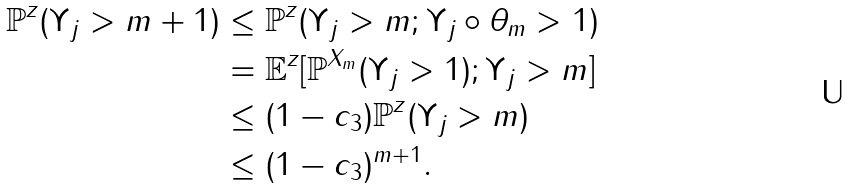<formula> <loc_0><loc_0><loc_500><loc_500>\mathbb { P } ^ { z } ( \Upsilon _ { j } > m + 1 ) & \leq \mathbb { P } ^ { z } ( \Upsilon _ { j } > m ; \Upsilon _ { j } \circ \theta _ { m } > 1 ) \\ & = \mathbb { E } ^ { z } [ \mathbb { P } ^ { X _ { m } } ( \Upsilon _ { j } > 1 ) ; \Upsilon _ { j } > m ] \\ & \leq ( 1 - c _ { 3 } ) \mathbb { P } ^ { z } ( \Upsilon _ { j } > m ) \\ & \leq ( 1 - c _ { 3 } ) ^ { m + 1 } .</formula> 